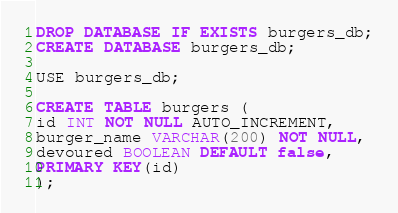<code> <loc_0><loc_0><loc_500><loc_500><_SQL_>DROP DATABASE IF EXISTS burgers_db;
CREATE DATABASE burgers_db;

USE burgers_db;

CREATE TABLE burgers (
id INT NOT NULL AUTO_INCREMENT,
burger_name VARCHAR(200) NOT NULL,
devoured BOOLEAN DEFAULT false,
PRIMARY KEY(id)
);</code> 